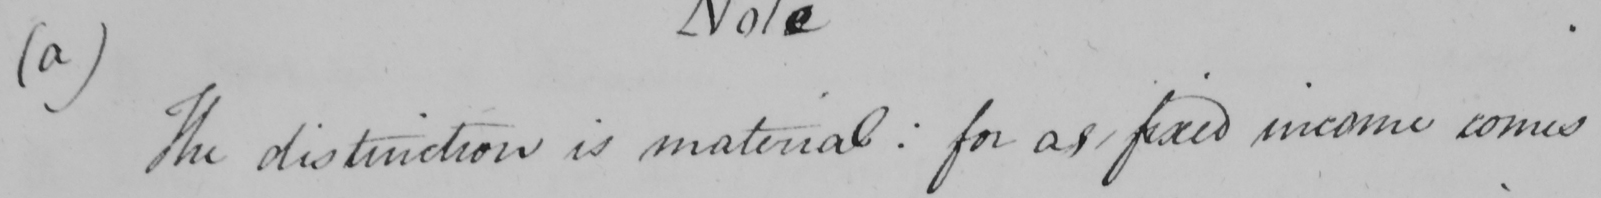What is written in this line of handwriting? (a)The distinction is material: for as fixed income comes 